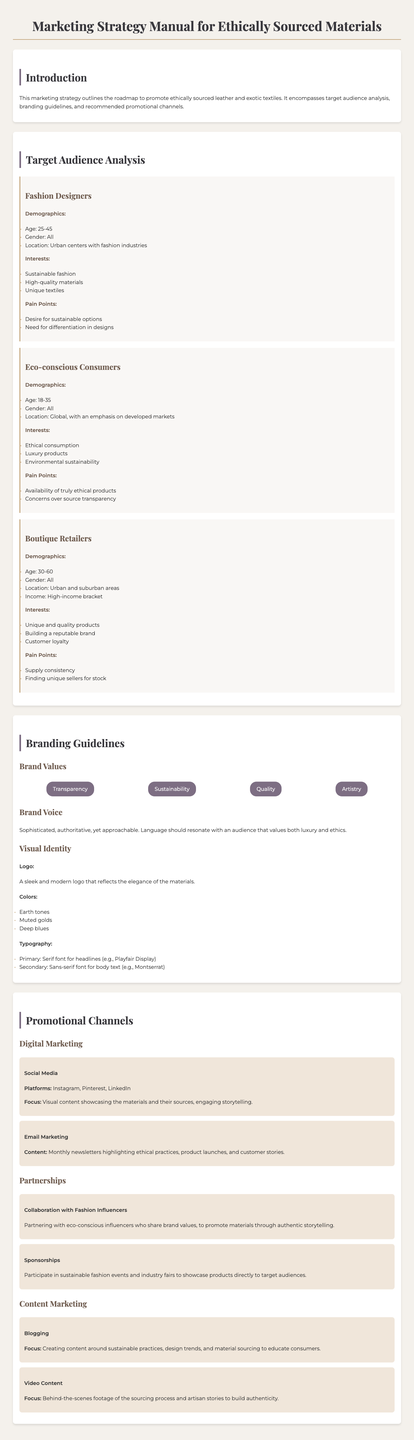What is the title of the manual? The title is stated prominently at the top of the document.
Answer: Marketing Strategy Manual for Ethically Sourced Materials What is the age range of fashion designers? The demographics section lists the age range specifically for fashion designers.
Answer: 25-45 Name a target audience for the marketing strategy. Various audience segments are detailed in the document's target audience analysis.
Answer: Fashion Designers What are the brand values listed in the manual? The document outlines key brand values associated with the marketing strategy.
Answer: Transparency, Sustainability, Quality, Artistry Which social media platforms are mentioned for digital marketing? The document specifies the platforms to be used for social media marketing.
Answer: Instagram, Pinterest, LinkedIn What is the primary focus of blogging in content marketing? The section on content marketing explains the focus areas for the blogging strategy.
Answer: Creating content around sustainable practices What pain point do eco-conscious consumers have? The pain points section under target audiences details challenges faced by eco-conscious consumers.
Answer: Availability of truly ethical products What type of events does the manual suggest for sponsorships? The promotional channels section mentions the types of events for sponsorship.
Answer: Sustainable fashion events What is the brand voice described in the guidelines? The branding guidelines section provides a description of the brand voice.
Answer: Sophisticated, authoritative, yet approachable 